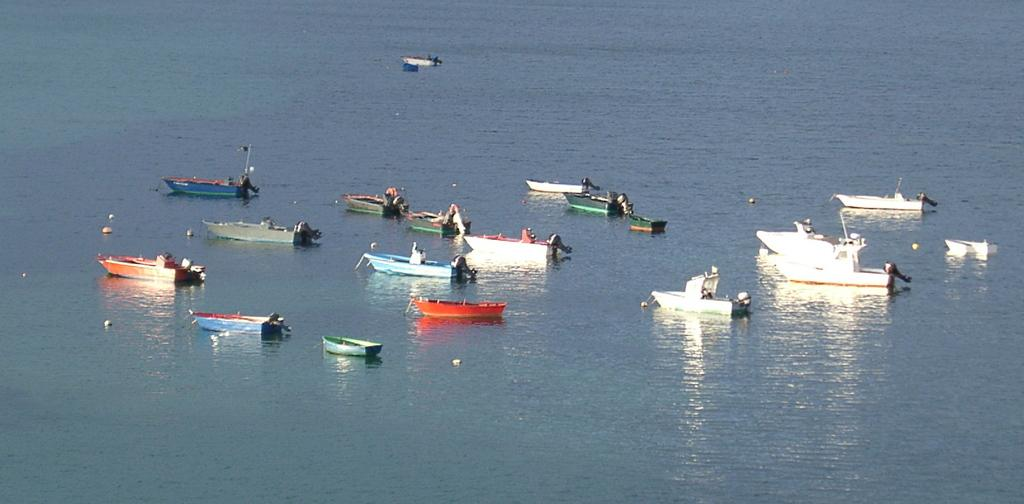What is the main subject of the image? The main subject of the image is many boats. What are the boats doing in the image? The boats are floating on the water. What can be seen in the background of the image? The background of the image is water. What is the thought process of the water in the image? There is no thought process associated with water in the image, as water is an inanimate object and does not have thoughts or a thought process. 